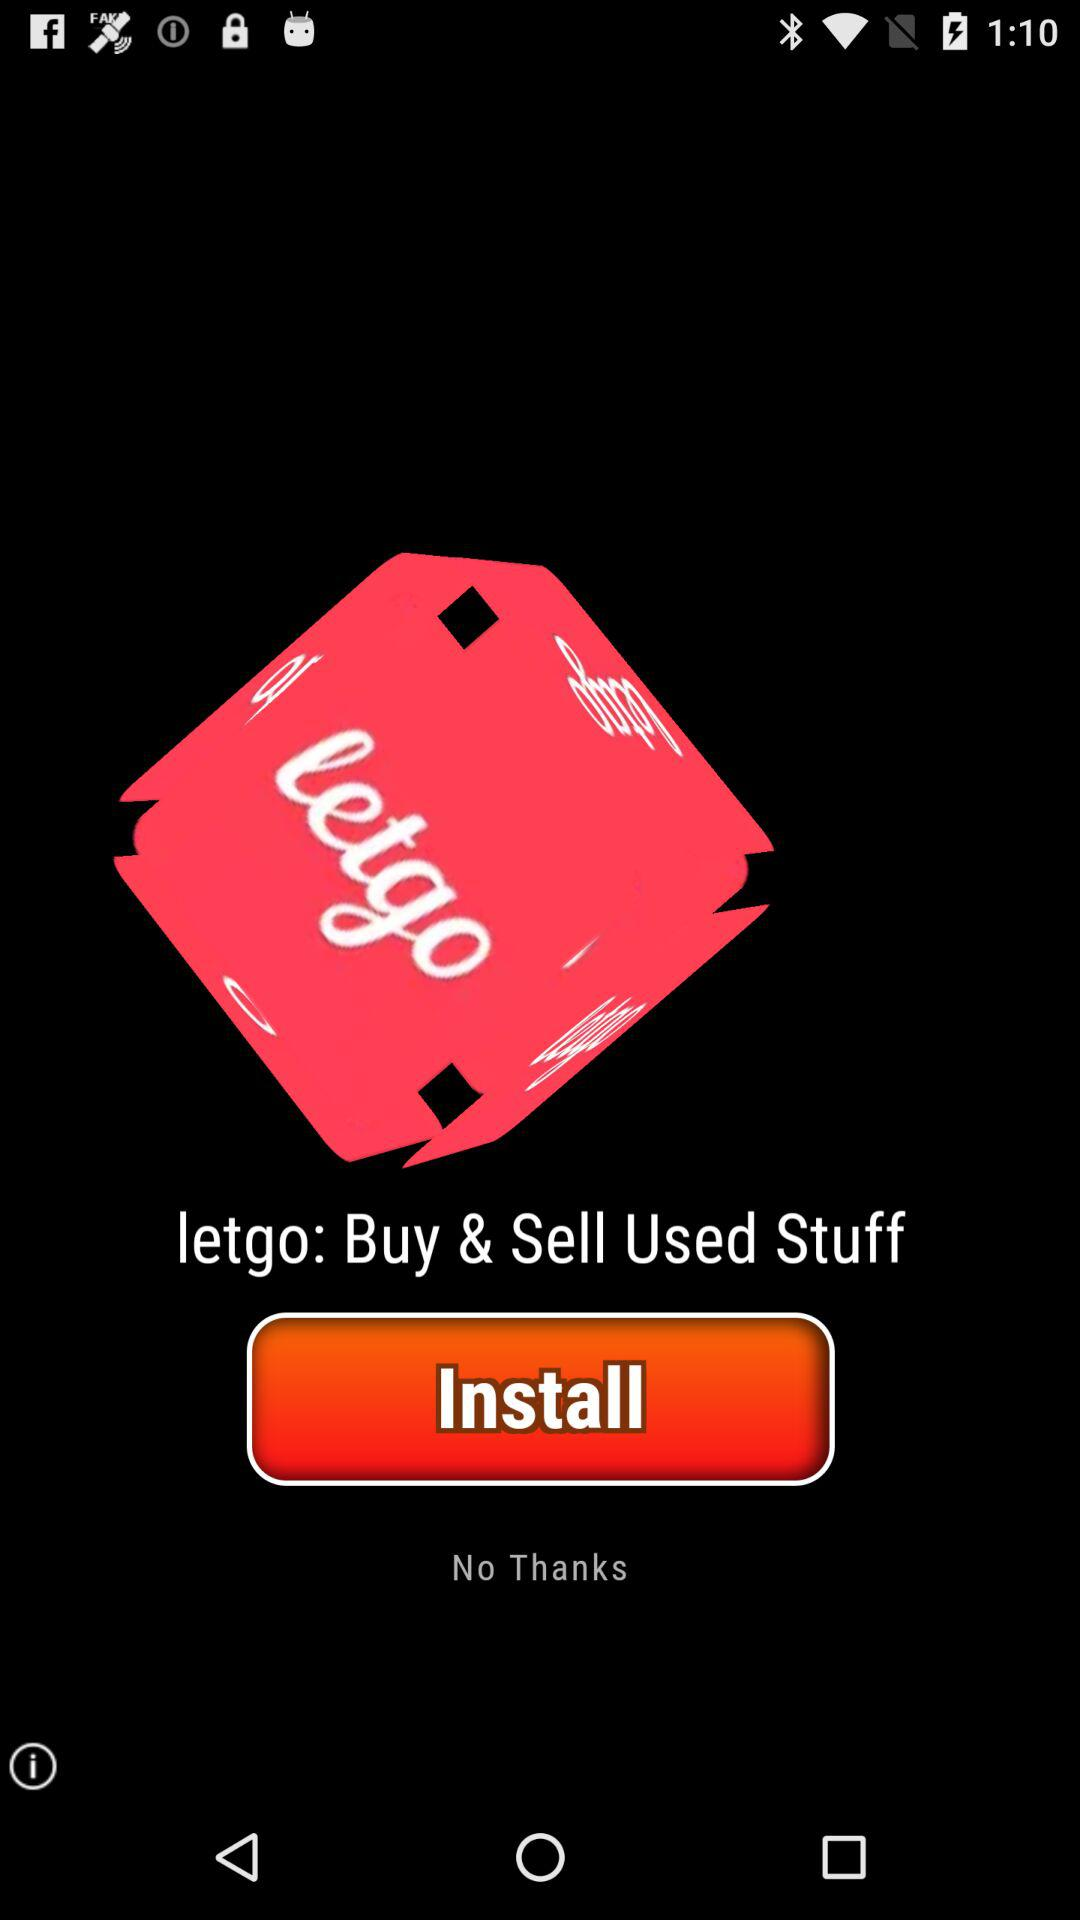What is the application name? The application name is "letgo". 